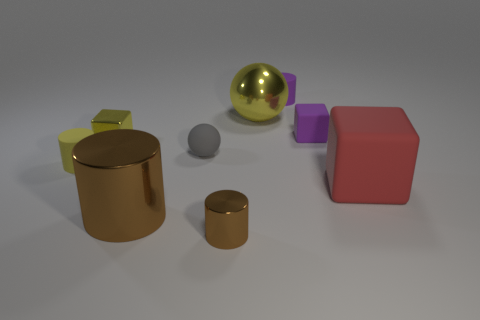How many big objects are yellow rubber cylinders or gray matte spheres?
Offer a very short reply. 0. Is there a matte ball that is behind the yellow metal object right of the gray matte object?
Provide a short and direct response. No. Is there a large green sphere?
Offer a terse response. No. What color is the small object on the right side of the matte cylinder that is behind the tiny rubber sphere?
Offer a very short reply. Purple. There is a big red object that is the same shape as the small yellow shiny thing; what material is it?
Keep it short and to the point. Rubber. How many gray matte balls have the same size as the yellow cube?
Give a very brief answer. 1. There is a ball that is the same material as the tiny yellow block; what size is it?
Make the answer very short. Large. What number of small gray matte things are the same shape as the big yellow object?
Your answer should be compact. 1. How many brown metal cubes are there?
Your response must be concise. 0. Is the shape of the brown thing that is on the left side of the tiny brown cylinder the same as  the large red rubber object?
Keep it short and to the point. No. 